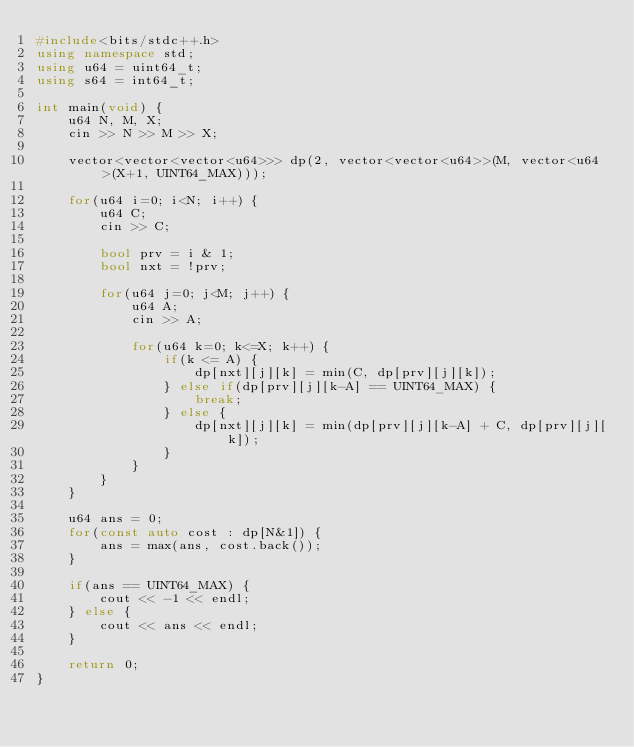<code> <loc_0><loc_0><loc_500><loc_500><_C++_>#include<bits/stdc++.h>
using namespace std;
using u64 = uint64_t;
using s64 = int64_t;

int main(void) {
    u64 N, M, X;
    cin >> N >> M >> X;
    
    vector<vector<vector<u64>>> dp(2, vector<vector<u64>>(M, vector<u64>(X+1, UINT64_MAX)));

    for(u64 i=0; i<N; i++) {
        u64 C;
        cin >> C;

        bool prv = i & 1;
        bool nxt = !prv;

        for(u64 j=0; j<M; j++) {
            u64 A;
            cin >> A;

            for(u64 k=0; k<=X; k++) {
                if(k <= A) {
                    dp[nxt][j][k] = min(C, dp[prv][j][k]);
                } else if(dp[prv][j][k-A] == UINT64_MAX) {
                    break;
                } else {
                    dp[nxt][j][k] = min(dp[prv][j][k-A] + C, dp[prv][j][k]);
                }
            }
        }
    }

    u64 ans = 0;
    for(const auto cost : dp[N&1]) {
        ans = max(ans, cost.back());
    }

    if(ans == UINT64_MAX) {
        cout << -1 << endl;
    } else {
        cout << ans << endl;
    }

    return 0;
}</code> 